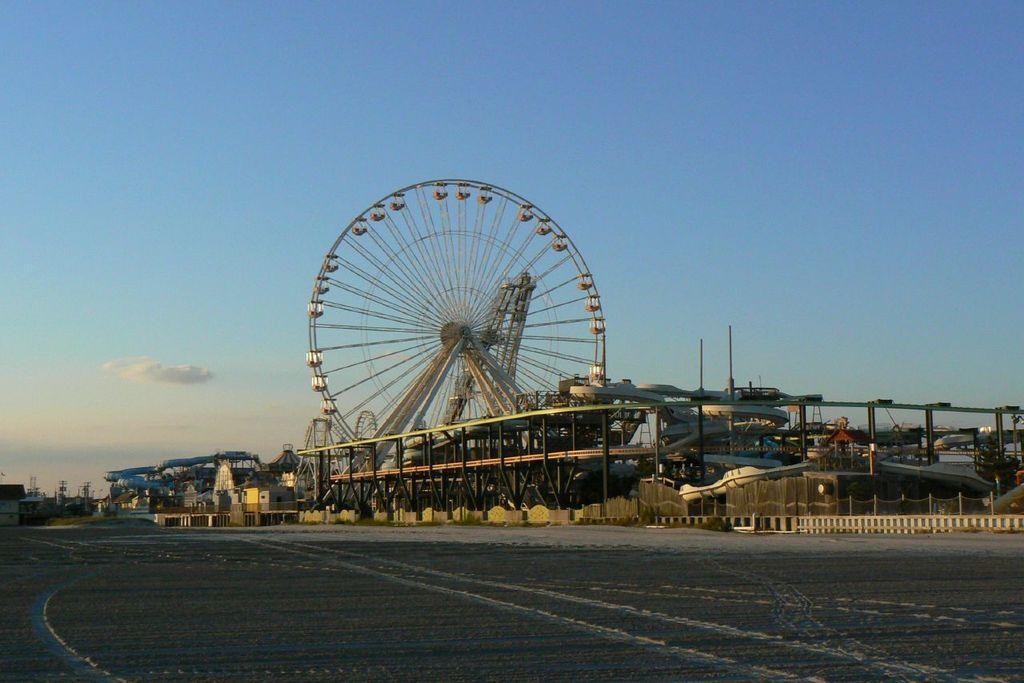In one or two sentences, can you explain what this image depicts? In this picture I can see the wheel. Beside that I can see the sheds, buildings, roller coasters and other objects. At the bottom there is a road. On the right I can see the gate and fencing. At the top I can see the sky and clouds. 